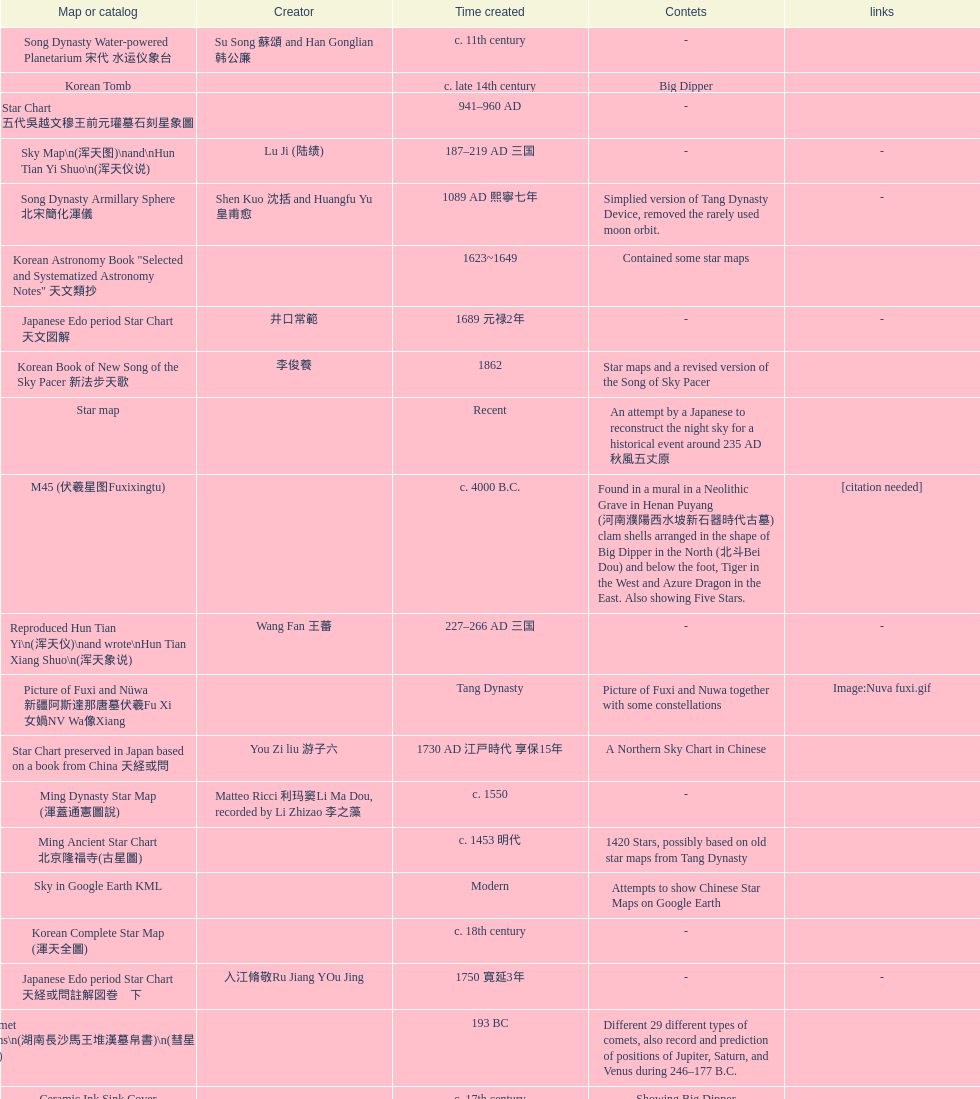Which was the first chinese star map known to have been created? M45 (伏羲星图Fuxixingtu). 